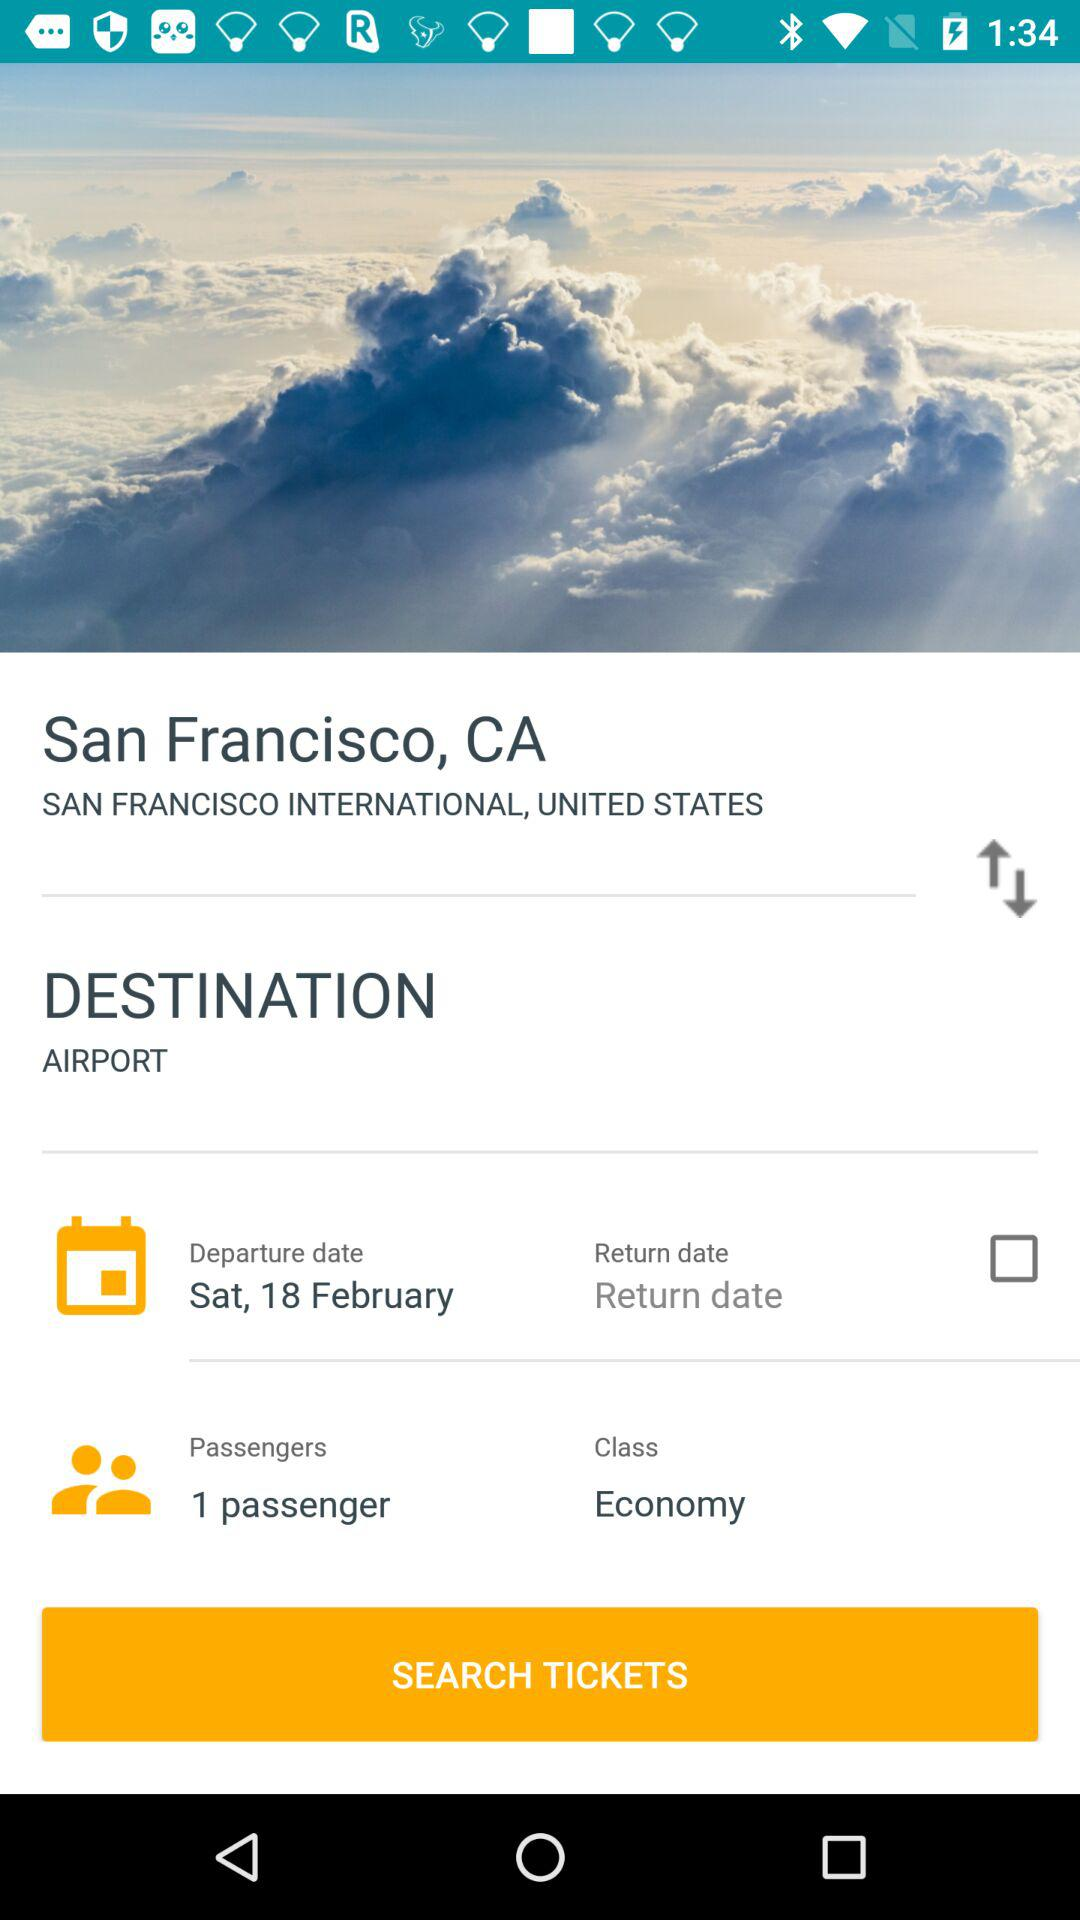What's the departure date? The departure date is Saturday, February 18. 